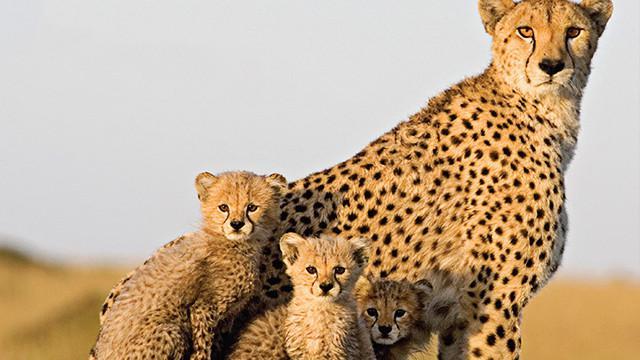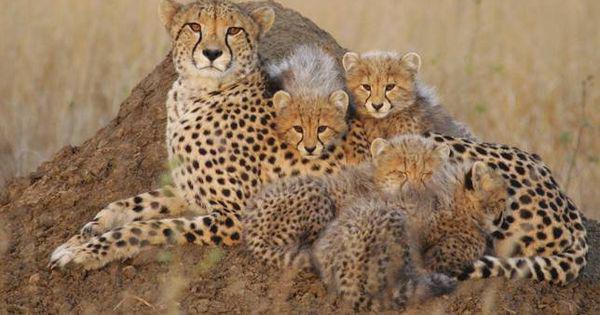The first image is the image on the left, the second image is the image on the right. Examine the images to the left and right. Is the description "The left image includes exactly one spotted wild cat." accurate? Answer yes or no. No. The first image is the image on the left, the second image is the image on the right. For the images shown, is this caption "The leopard in the image on the left is sitting with her kittens." true? Answer yes or no. Yes. 